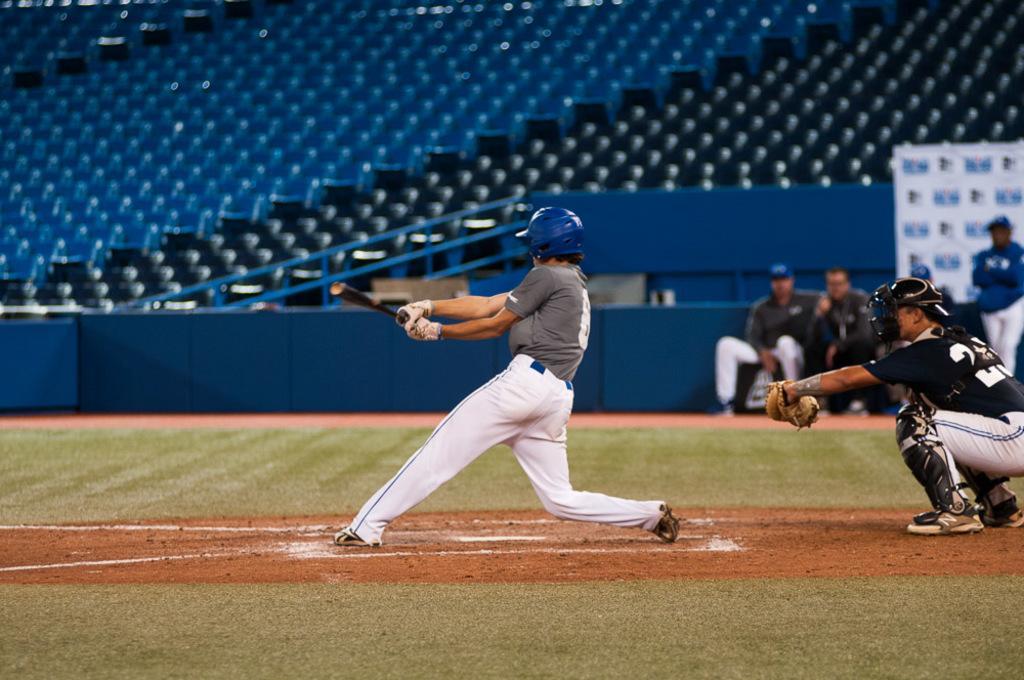Can you describe this image briefly? In this image I can see a person wearing grey and white colored dress and blue color helmet is standing and holding a bat in his hand. I can see another person behind him. In the background I can see few persons sitting, a person standing, the railing and number of seats which are black and blue in color in the stadium. 